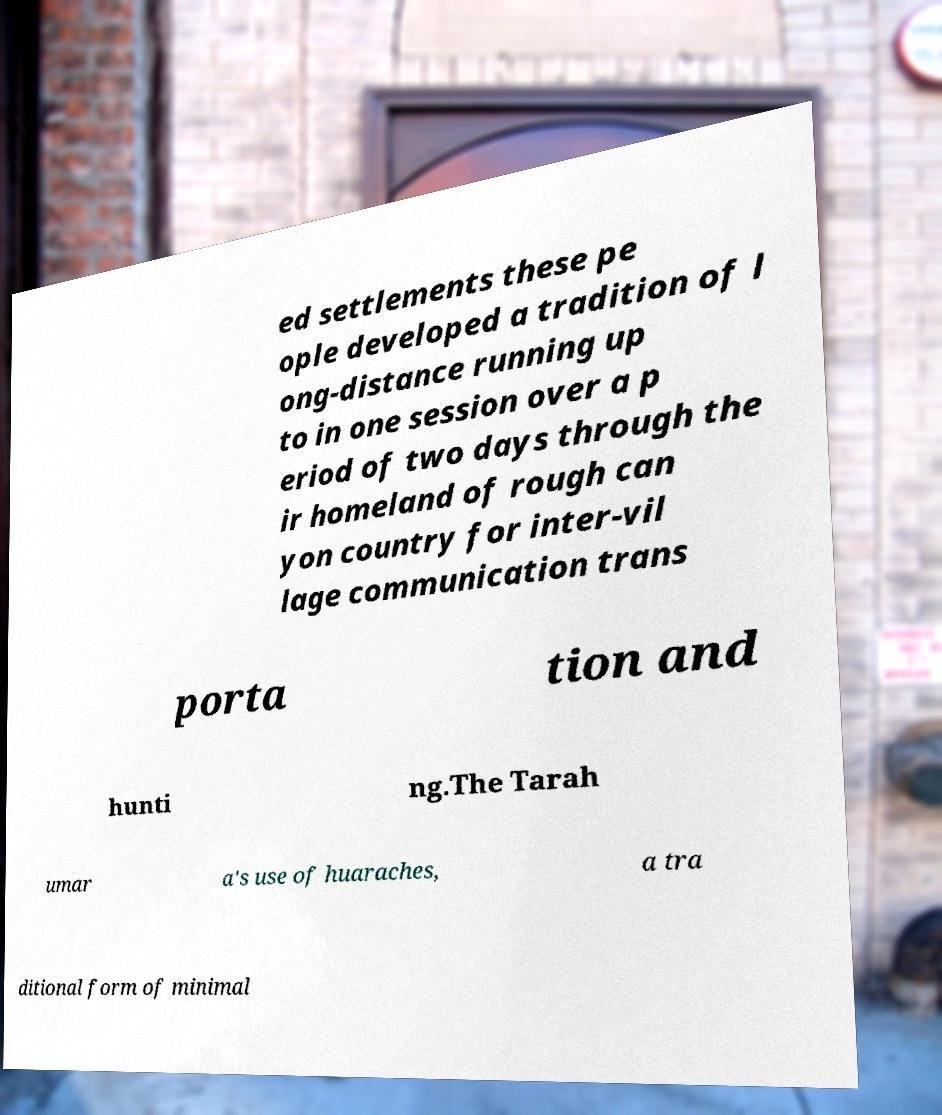Can you accurately transcribe the text from the provided image for me? ed settlements these pe ople developed a tradition of l ong-distance running up to in one session over a p eriod of two days through the ir homeland of rough can yon country for inter-vil lage communication trans porta tion and hunti ng.The Tarah umar a's use of huaraches, a tra ditional form of minimal 